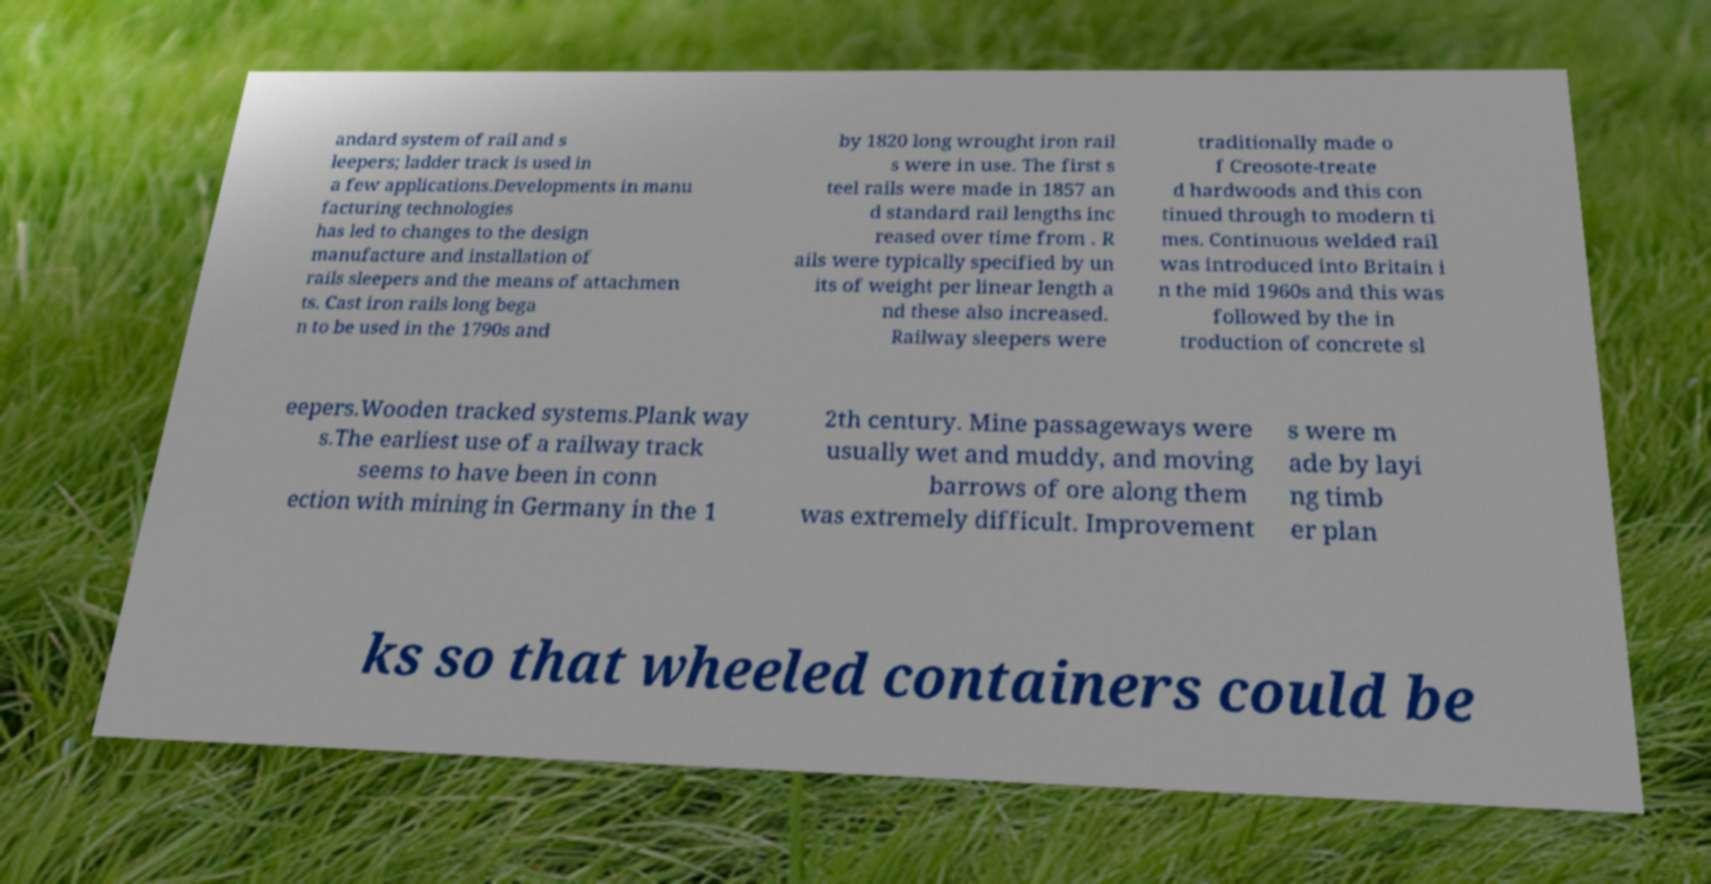What messages or text are displayed in this image? I need them in a readable, typed format. andard system of rail and s leepers; ladder track is used in a few applications.Developments in manu facturing technologies has led to changes to the design manufacture and installation of rails sleepers and the means of attachmen ts. Cast iron rails long bega n to be used in the 1790s and by 1820 long wrought iron rail s were in use. The first s teel rails were made in 1857 an d standard rail lengths inc reased over time from . R ails were typically specified by un its of weight per linear length a nd these also increased. Railway sleepers were traditionally made o f Creosote-treate d hardwoods and this con tinued through to modern ti mes. Continuous welded rail was introduced into Britain i n the mid 1960s and this was followed by the in troduction of concrete sl eepers.Wooden tracked systems.Plank way s.The earliest use of a railway track seems to have been in conn ection with mining in Germany in the 1 2th century. Mine passageways were usually wet and muddy, and moving barrows of ore along them was extremely difficult. Improvement s were m ade by layi ng timb er plan ks so that wheeled containers could be 